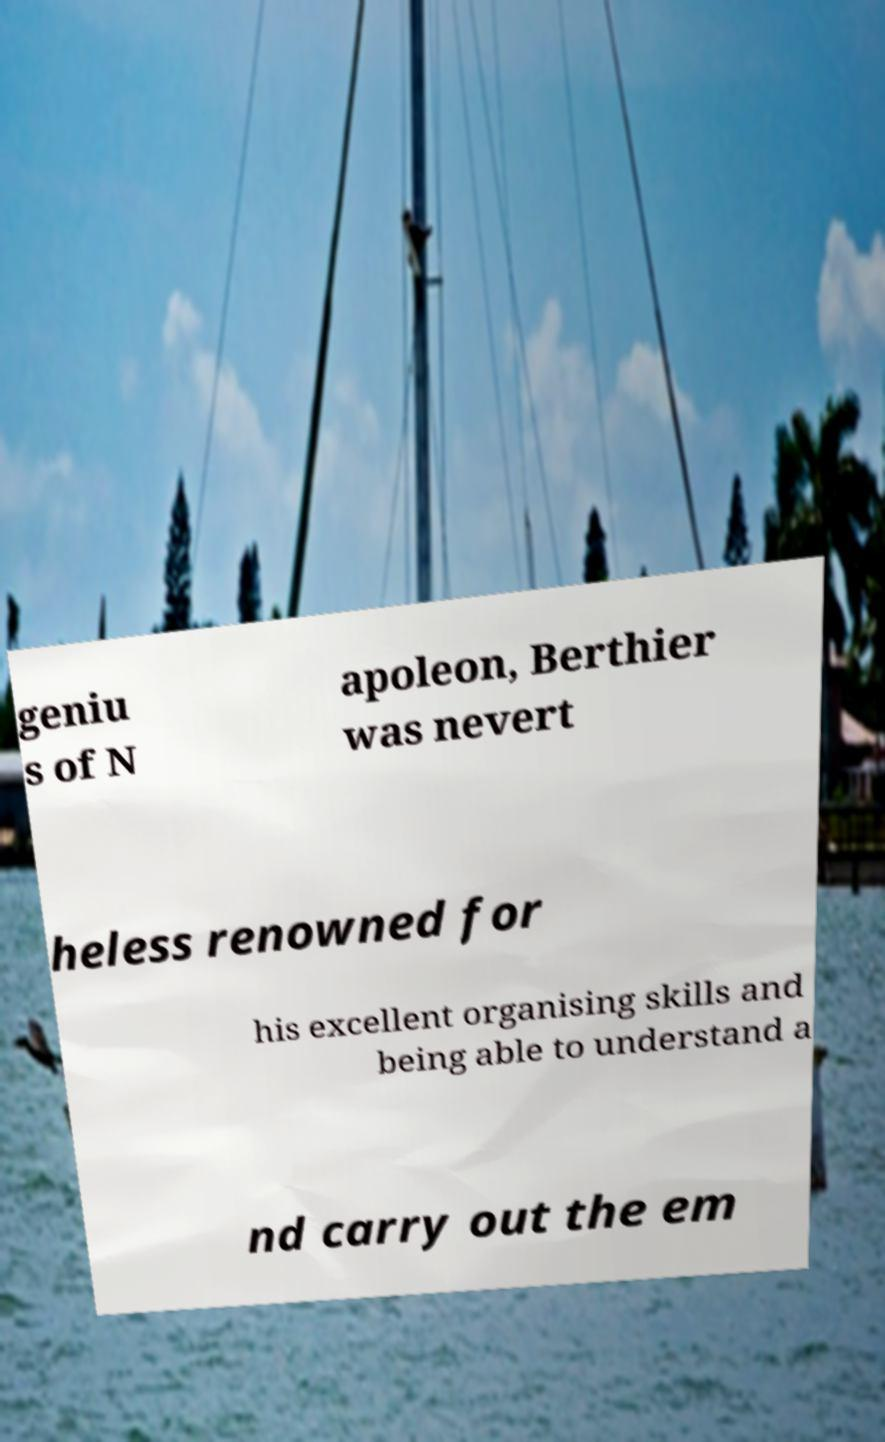Could you assist in decoding the text presented in this image and type it out clearly? geniu s of N apoleon, Berthier was nevert heless renowned for his excellent organising skills and being able to understand a nd carry out the em 